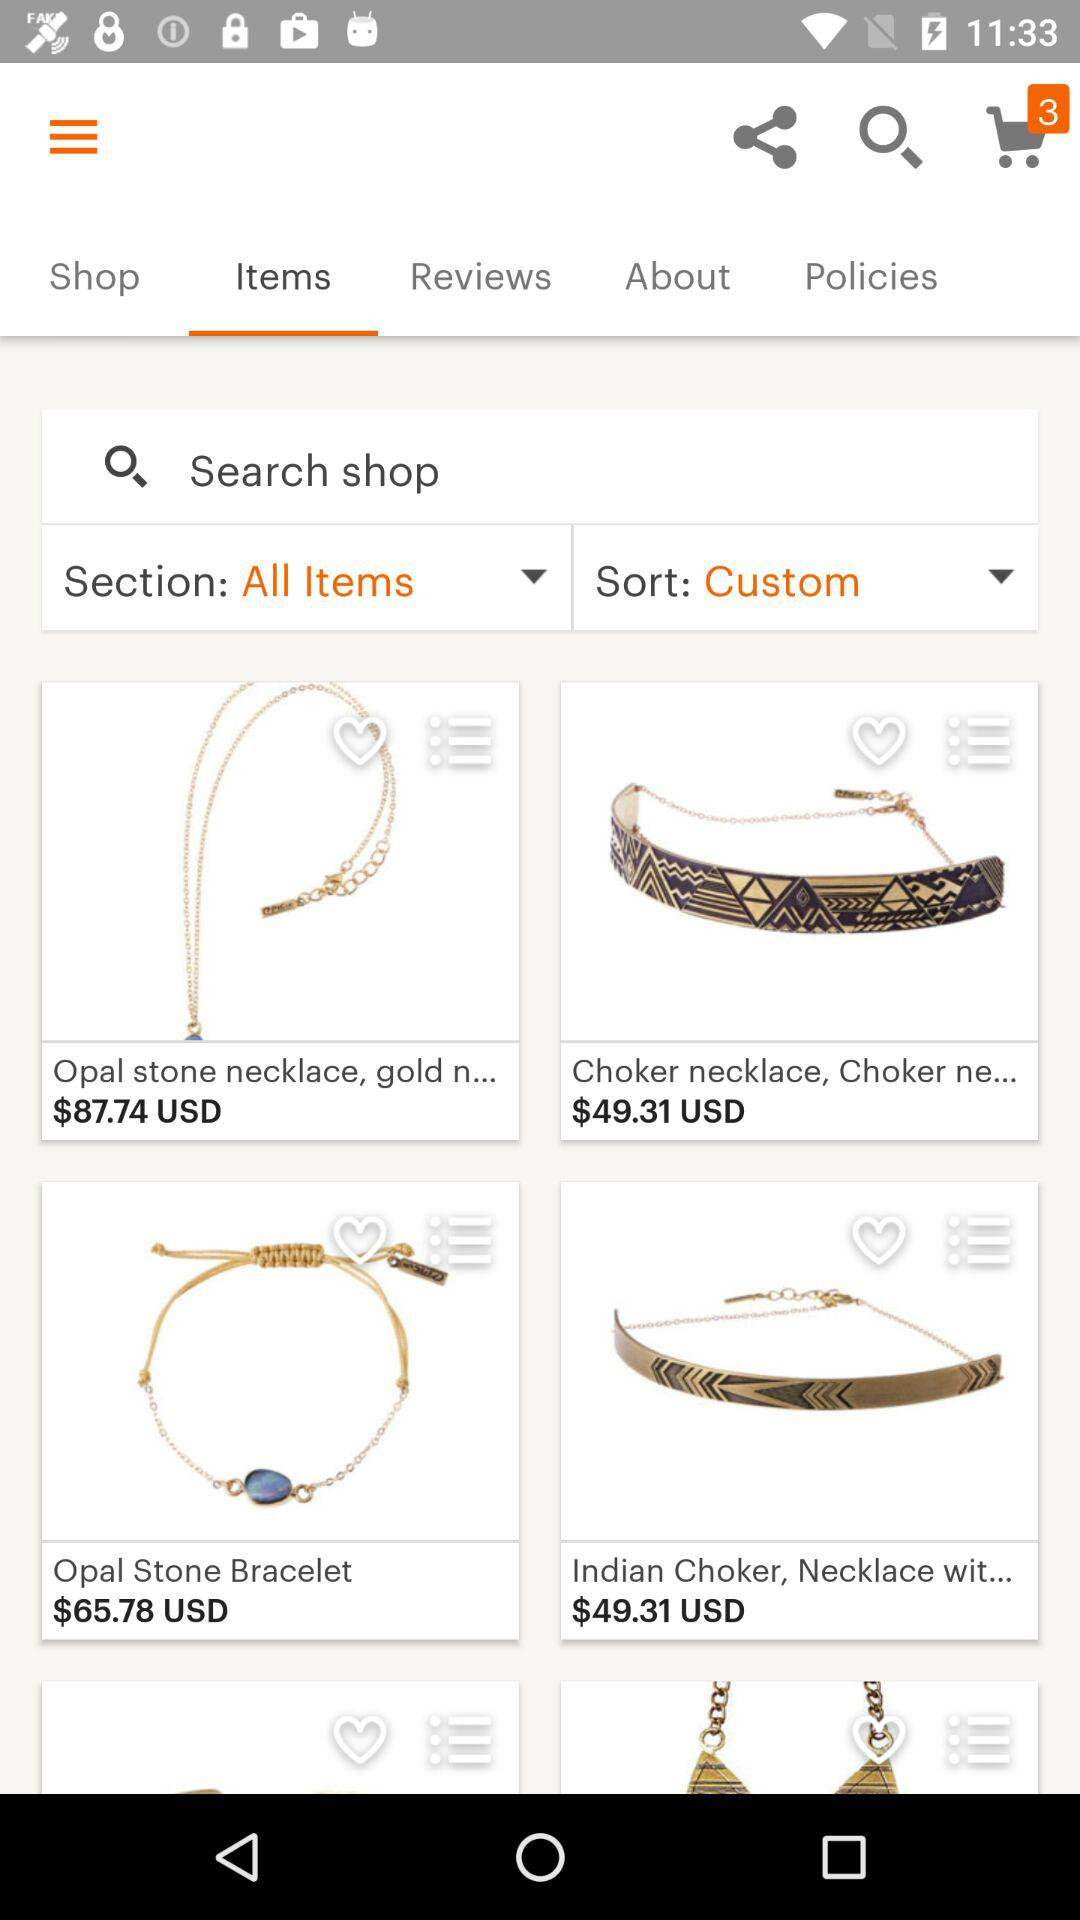How many items are in the second row?
Answer the question using a single word or phrase. 2 